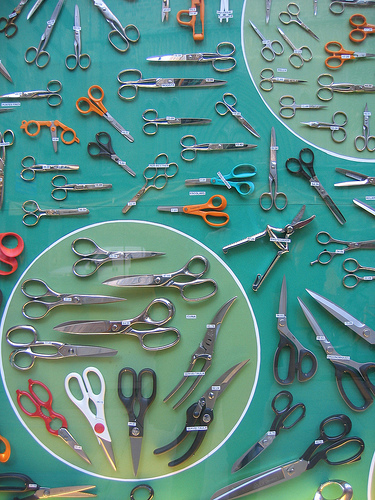If this image were part of a mystery novel, what could be the significance of these scissors? In a mystery novel, this collection of scissors could be a crucial clue. Each pair of scissors might have a hidden meaning or a secret code engraved on them. Perhaps a particular pair has a trace of fabric or a strand of hair that links it to a cunning crime. The protagonist may need to discern these subtle hints to uncover the truth behind the enigma. The sheer variety of scissors could symbolize the complexity of the mystery, where every detail leading to the resolution is intricate and significant. 